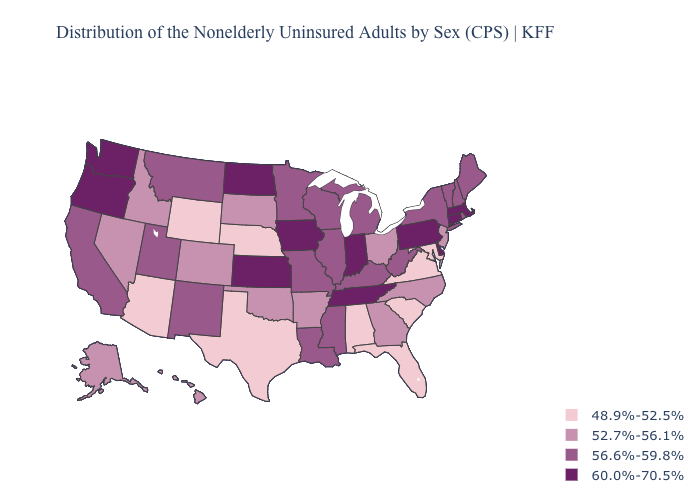Which states hav the highest value in the Northeast?
Quick response, please. Connecticut, Massachusetts, Pennsylvania. Does the first symbol in the legend represent the smallest category?
Write a very short answer. Yes. What is the highest value in the USA?
Short answer required. 60.0%-70.5%. Does Illinois have the highest value in the USA?
Answer briefly. No. What is the value of New Hampshire?
Keep it brief. 56.6%-59.8%. Does South Dakota have the highest value in the USA?
Keep it brief. No. Does the map have missing data?
Write a very short answer. No. Name the states that have a value in the range 52.7%-56.1%?
Give a very brief answer. Alaska, Arkansas, Colorado, Georgia, Hawaii, Idaho, Nevada, New Jersey, North Carolina, Ohio, Oklahoma, South Dakota. Does Arizona have the lowest value in the West?
Concise answer only. Yes. What is the value of Delaware?
Give a very brief answer. 60.0%-70.5%. Which states have the lowest value in the USA?
Give a very brief answer. Alabama, Arizona, Florida, Maryland, Nebraska, South Carolina, Texas, Virginia, Wyoming. Which states have the lowest value in the South?
Short answer required. Alabama, Florida, Maryland, South Carolina, Texas, Virginia. Among the states that border Wyoming , does Montana have the highest value?
Keep it brief. Yes. Does North Carolina have a lower value than California?
Concise answer only. Yes. Name the states that have a value in the range 48.9%-52.5%?
Quick response, please. Alabama, Arizona, Florida, Maryland, Nebraska, South Carolina, Texas, Virginia, Wyoming. 